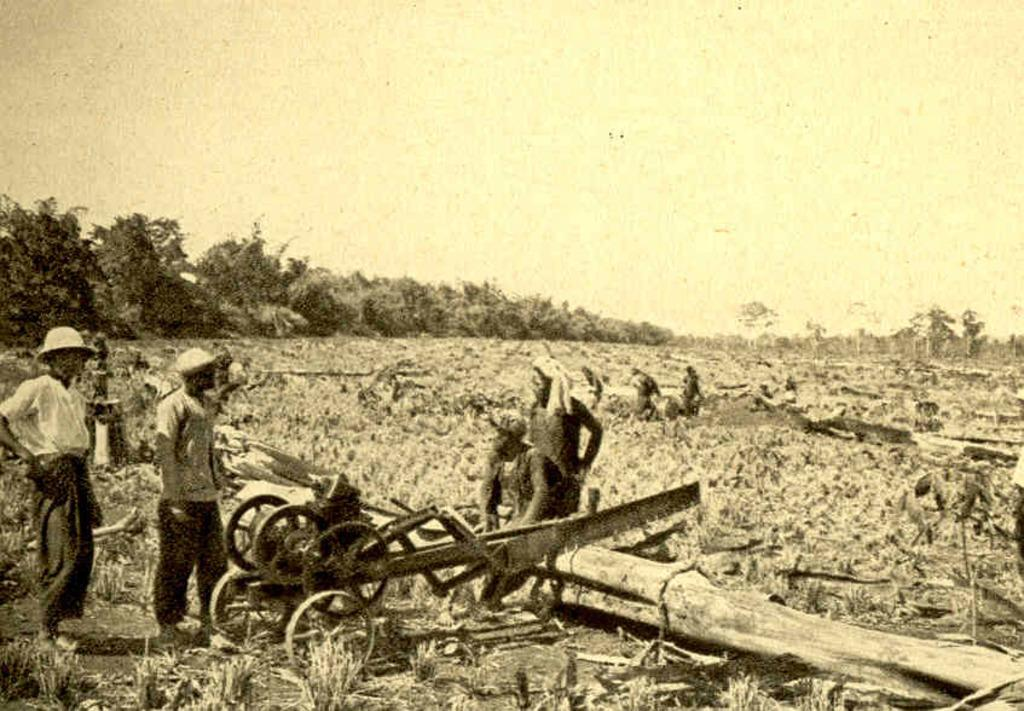Who or what can be seen in the image? There are people in the image. What type of natural environment is depicted in the image? There are trees and grass in the image. What material is present in the image? There is wood in the image. What tool is being used by the people in the image? There is a wood cutter in the image. What can be seen in the background of the image? The sky is visible in the background of the image. What type of berry can be seen growing on the trees in the image? There is no berry growing on the trees in the image; only trees and grass are visible. What is the stick used for in the image? There is no stick present in the image. 